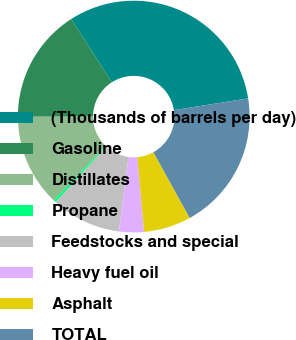Convert chart to OTSL. <chart><loc_0><loc_0><loc_500><loc_500><pie_chart><fcel>(Thousands of barrels per day)<fcel>Gasoline<fcel>Distillates<fcel>Propane<fcel>Feedstocks and special<fcel>Heavy fuel oil<fcel>Asphalt<fcel>TOTAL<nl><fcel>31.56%<fcel>15.96%<fcel>12.84%<fcel>0.36%<fcel>9.72%<fcel>3.48%<fcel>6.6%<fcel>19.48%<nl></chart> 